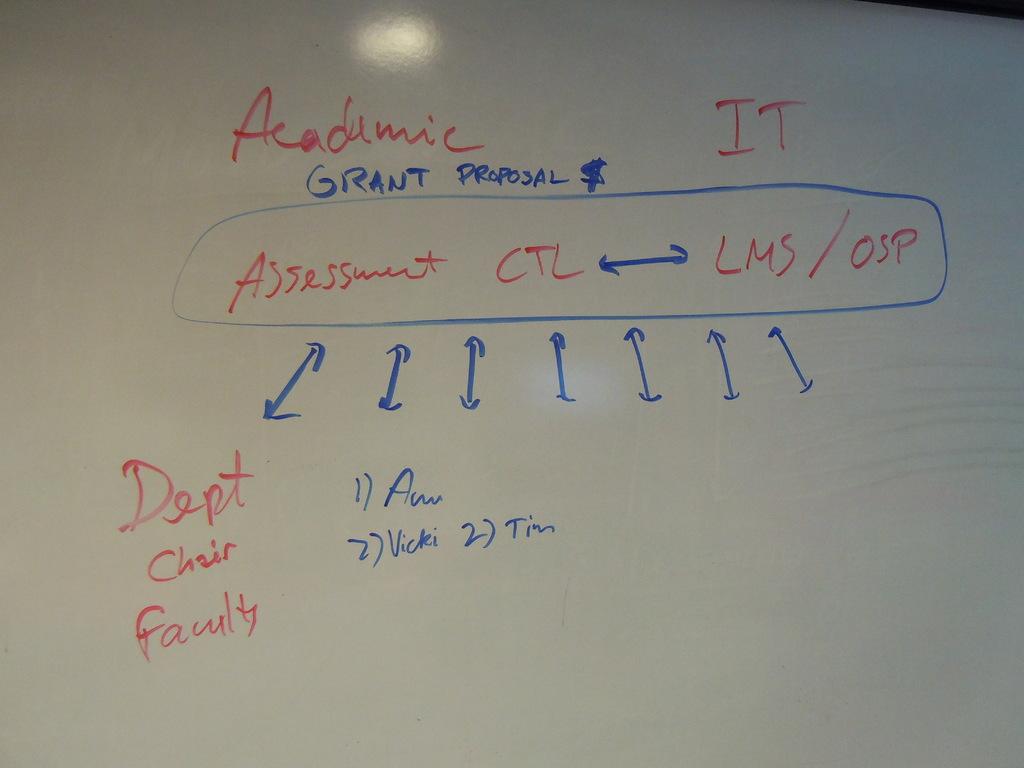What is the word before 'grant'?
Keep it short and to the point. Academic. 